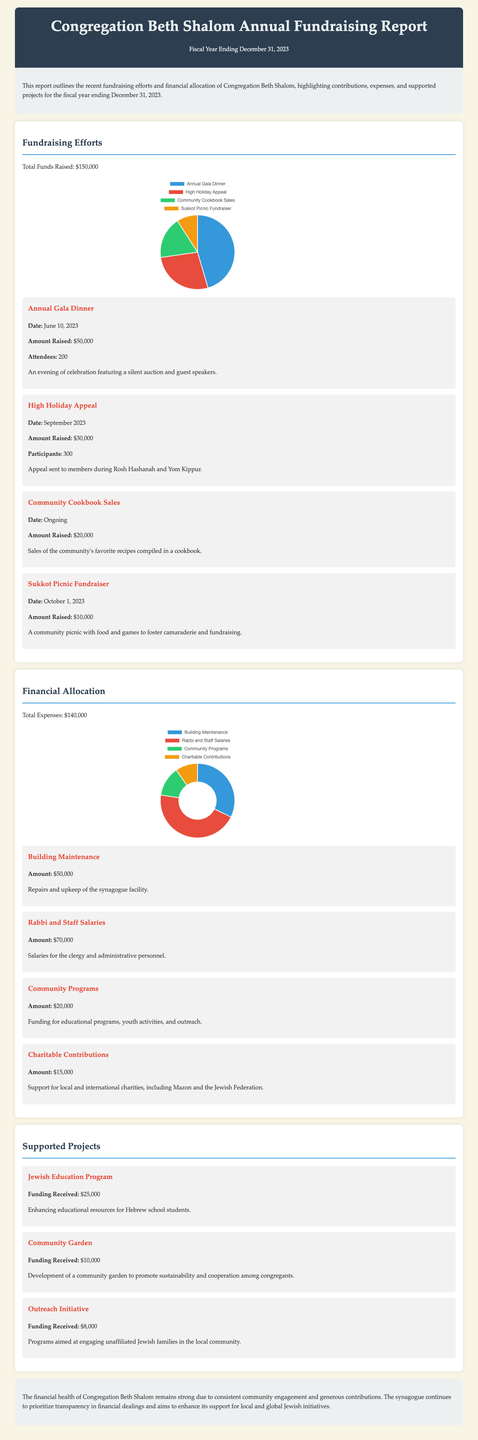What is the total funds raised? The total funds raised is explicitly stated in the document as $150,000.
Answer: $150,000 When was the Annual Gala Dinner held? The date of the Annual Gala Dinner is provided in the report as June 10, 2023.
Answer: June 10, 2023 How much was allocated for Rabbi and Staff Salaries? The amount allocated for Rabbi and Staff Salaries is outlined in the financial allocation section as $70,000.
Answer: $70,000 What project received funding of $25,000? The project that received funding of $25,000 is the Jewish Education Program mentioned in the supported projects section.
Answer: Jewish Education Program What percentage of the total funds raised came from the High Holiday Appeal? The amount raised from the High Holiday Appeal is $30,000, which is a portion of the total funds raised of $150,000, making it 20%.
Answer: 20% What is the total amount spent on Community Programs? The total amount spent on Community Programs is directly provided in the document as $20,000.
Answer: $20,000 What type of event is the Sukkot Picnic Fundraiser? The Sukkot Picnic Fundraiser is described as a community picnic with food and games.
Answer: Community picnic What was the total expense amount reported? The total expense amount is listed in the report as $140,000.
Answer: $140,000 What were the total charitable contributions made? The total charitable contributions made are specified in the financial allocation section as $15,000.
Answer: $15,000 